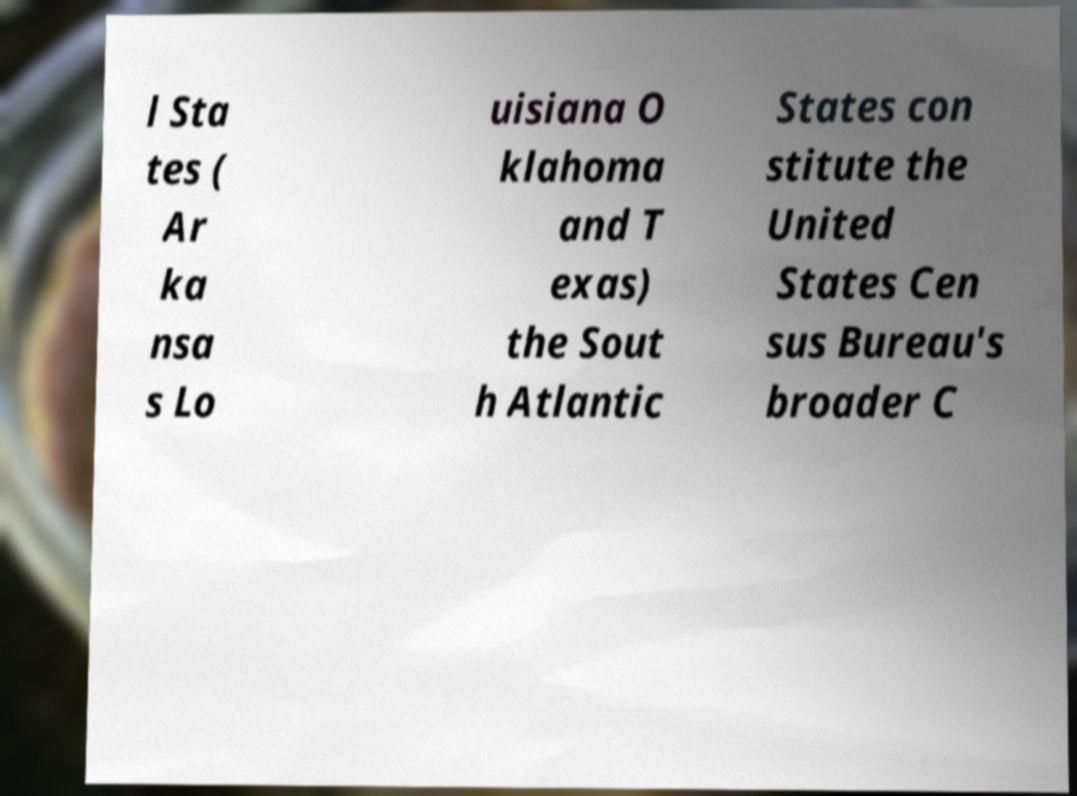Could you extract and type out the text from this image? l Sta tes ( Ar ka nsa s Lo uisiana O klahoma and T exas) the Sout h Atlantic States con stitute the United States Cen sus Bureau's broader C 